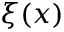<formula> <loc_0><loc_0><loc_500><loc_500>\xi ( x )</formula> 